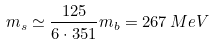<formula> <loc_0><loc_0><loc_500><loc_500>m _ { s } \simeq \frac { 1 2 5 } { 6 \cdot 3 5 1 } m _ { b } = 2 6 7 \, M e V</formula> 